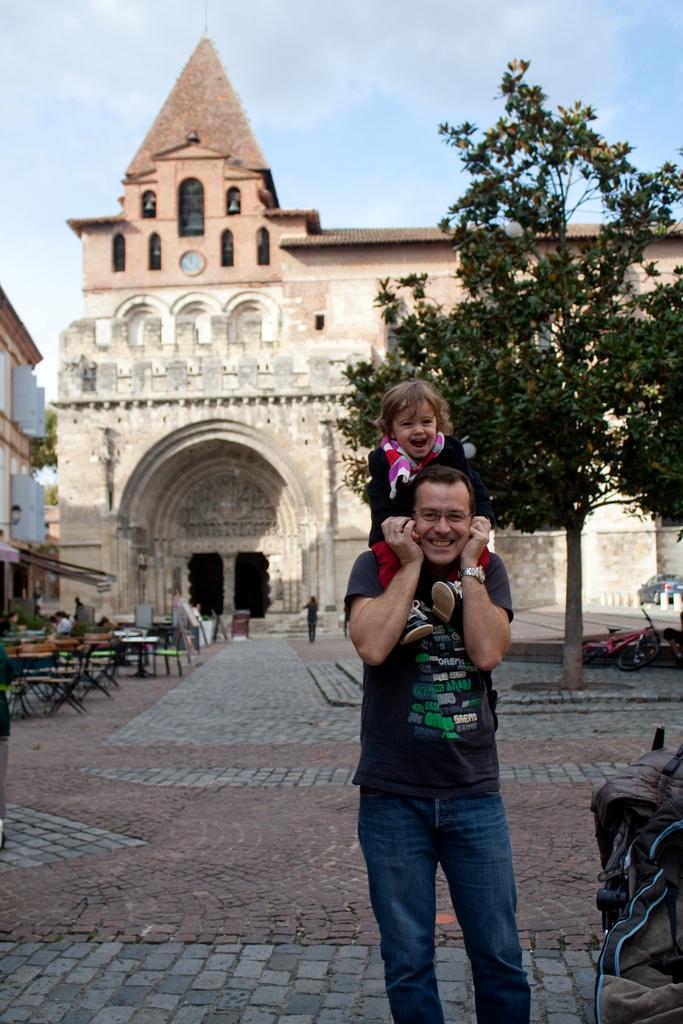Can you describe this image briefly? In this picture there are buildings and trees. In the foreground there is a man standing and smiling and holding the kid and there are bags. At back there are tables and chairs and there is a bicycle and car and there is a clock on the building. At the top there is sky and there are clouds. At the bottom there is a pavement. 